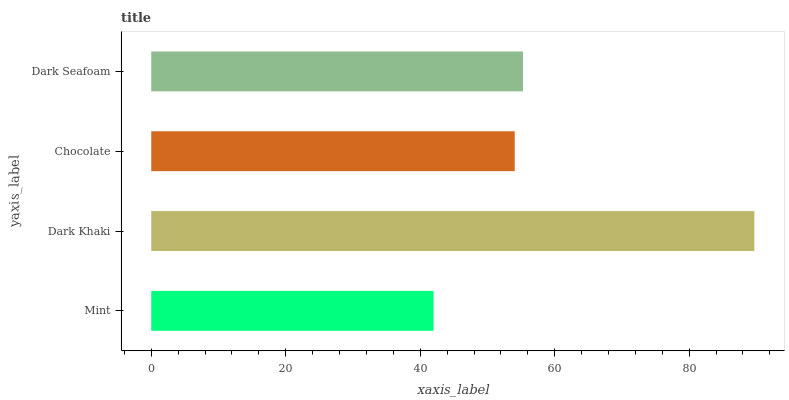Is Mint the minimum?
Answer yes or no. Yes. Is Dark Khaki the maximum?
Answer yes or no. Yes. Is Chocolate the minimum?
Answer yes or no. No. Is Chocolate the maximum?
Answer yes or no. No. Is Dark Khaki greater than Chocolate?
Answer yes or no. Yes. Is Chocolate less than Dark Khaki?
Answer yes or no. Yes. Is Chocolate greater than Dark Khaki?
Answer yes or no. No. Is Dark Khaki less than Chocolate?
Answer yes or no. No. Is Dark Seafoam the high median?
Answer yes or no. Yes. Is Chocolate the low median?
Answer yes or no. Yes. Is Mint the high median?
Answer yes or no. No. Is Mint the low median?
Answer yes or no. No. 